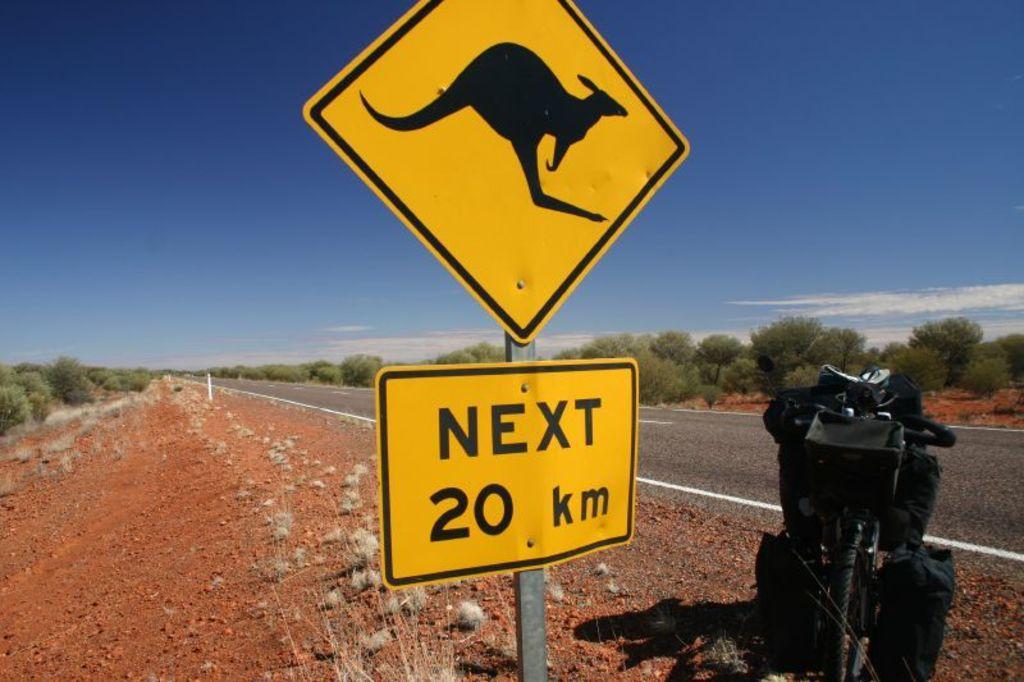Describe this image in one or two sentences. In this image, we can see sign boards with rod. Background there is a road, ground, trees and sky. Right side of the image, we can see bicycle and few objects. 